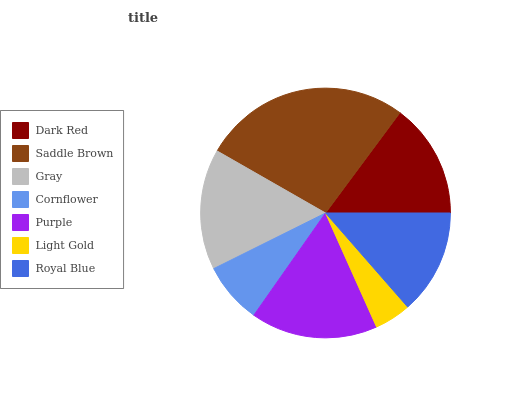Is Light Gold the minimum?
Answer yes or no. Yes. Is Saddle Brown the maximum?
Answer yes or no. Yes. Is Gray the minimum?
Answer yes or no. No. Is Gray the maximum?
Answer yes or no. No. Is Saddle Brown greater than Gray?
Answer yes or no. Yes. Is Gray less than Saddle Brown?
Answer yes or no. Yes. Is Gray greater than Saddle Brown?
Answer yes or no. No. Is Saddle Brown less than Gray?
Answer yes or no. No. Is Dark Red the high median?
Answer yes or no. Yes. Is Dark Red the low median?
Answer yes or no. Yes. Is Royal Blue the high median?
Answer yes or no. No. Is Purple the low median?
Answer yes or no. No. 